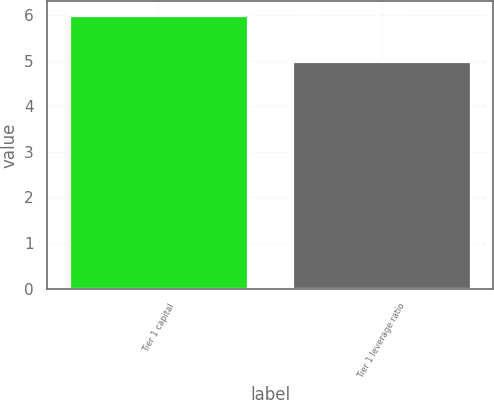Convert chart to OTSL. <chart><loc_0><loc_0><loc_500><loc_500><bar_chart><fcel>Tier 1 capital<fcel>Tier 1 leverage ratio<nl><fcel>6<fcel>5<nl></chart> 